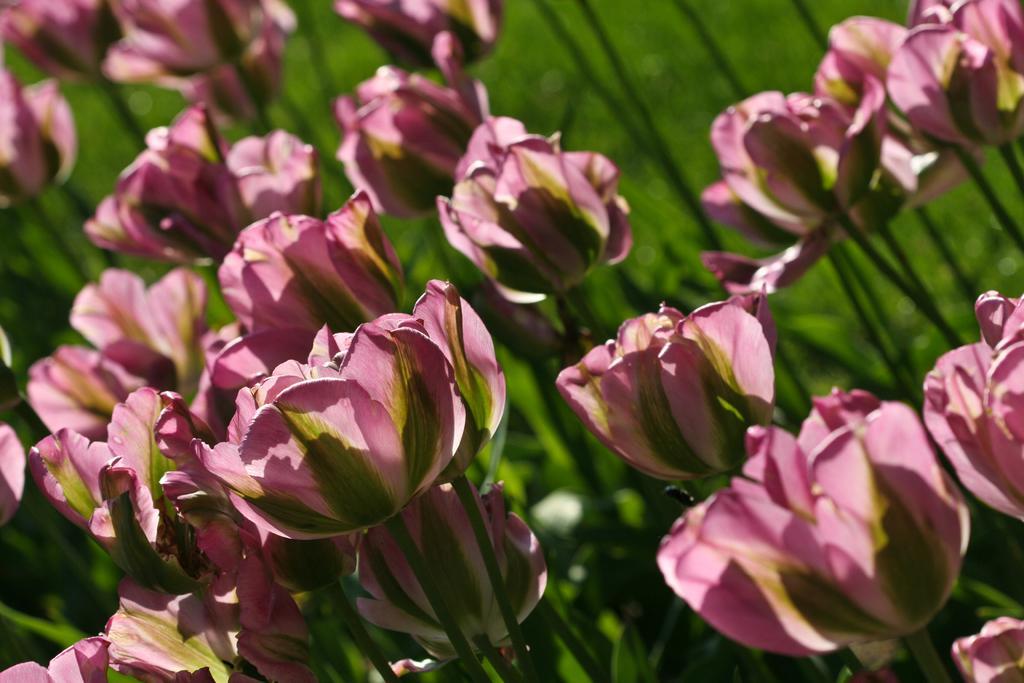How would you summarize this image in a sentence or two? There are plants having pink color flowers. And the background is green in color. 